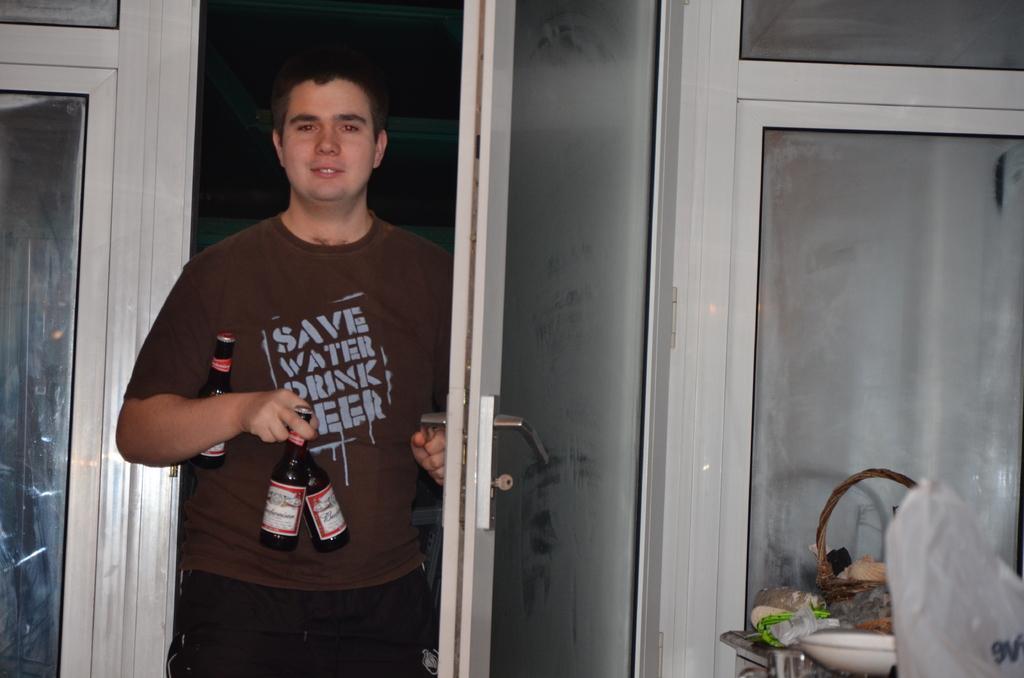Can you describe this image briefly? In this image i can see a man holding 3 beer bottles in his hands opening the door. To the right corner of the image i can see a bag and some objects on the countertop. 